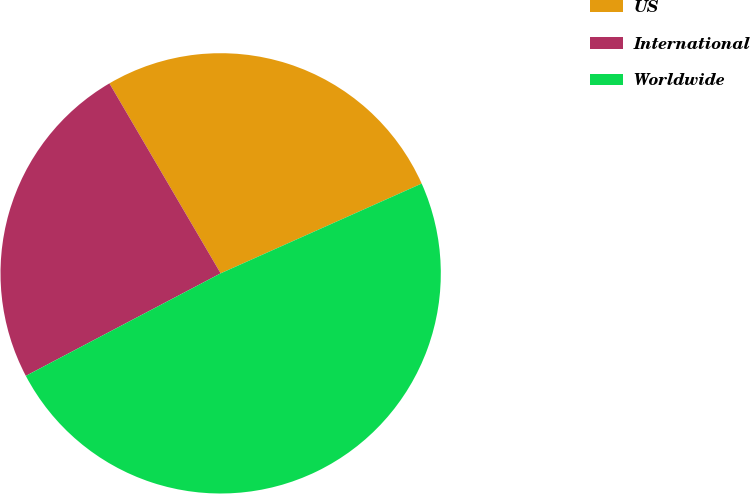Convert chart. <chart><loc_0><loc_0><loc_500><loc_500><pie_chart><fcel>US<fcel>International<fcel>Worldwide<nl><fcel>26.75%<fcel>24.28%<fcel>48.98%<nl></chart> 